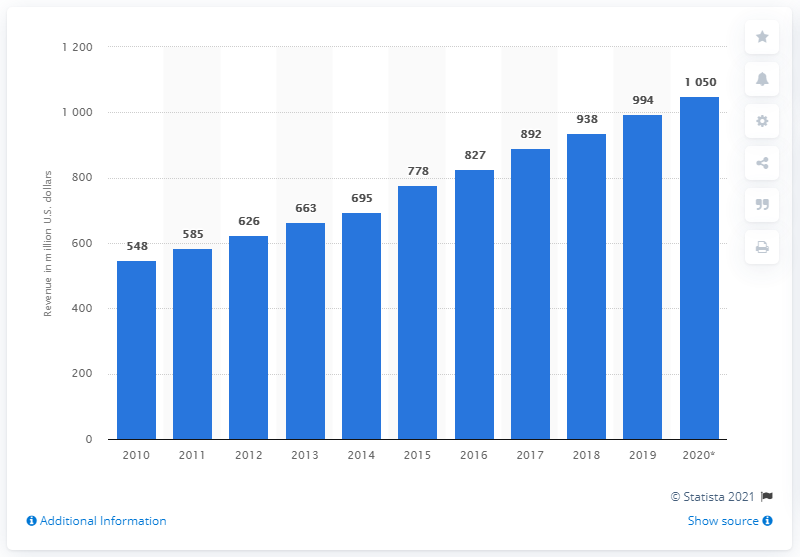Give some essential details in this illustration. In 2019, Major League Baseball generated approximately $994 million in sponsorship revenue. 